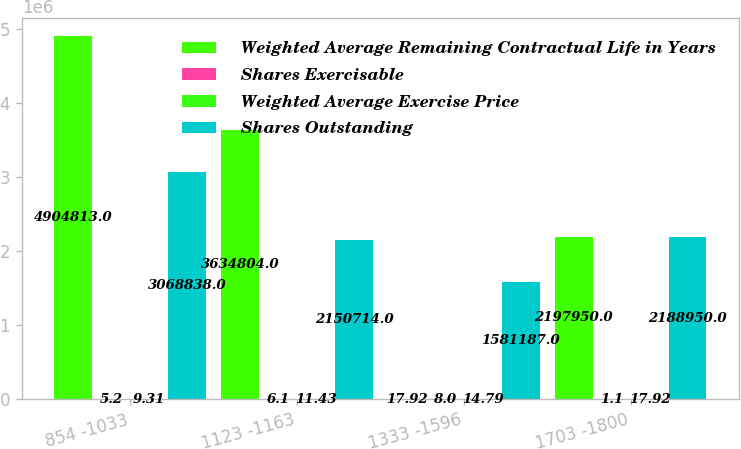<chart> <loc_0><loc_0><loc_500><loc_500><stacked_bar_chart><ecel><fcel>854 -1033<fcel>1123 -1163<fcel>1333 -1596<fcel>1703 -1800<nl><fcel>Weighted Average Remaining Contractual Life in Years<fcel>4.90481e+06<fcel>3.6348e+06<fcel>17.92<fcel>2.19795e+06<nl><fcel>Shares Exercisable<fcel>5.2<fcel>6.1<fcel>8<fcel>1.1<nl><fcel>Weighted Average Exercise Price<fcel>9.31<fcel>11.43<fcel>14.79<fcel>17.92<nl><fcel>Shares Outstanding<fcel>3.06884e+06<fcel>2.15071e+06<fcel>1.58119e+06<fcel>2.18895e+06<nl></chart> 